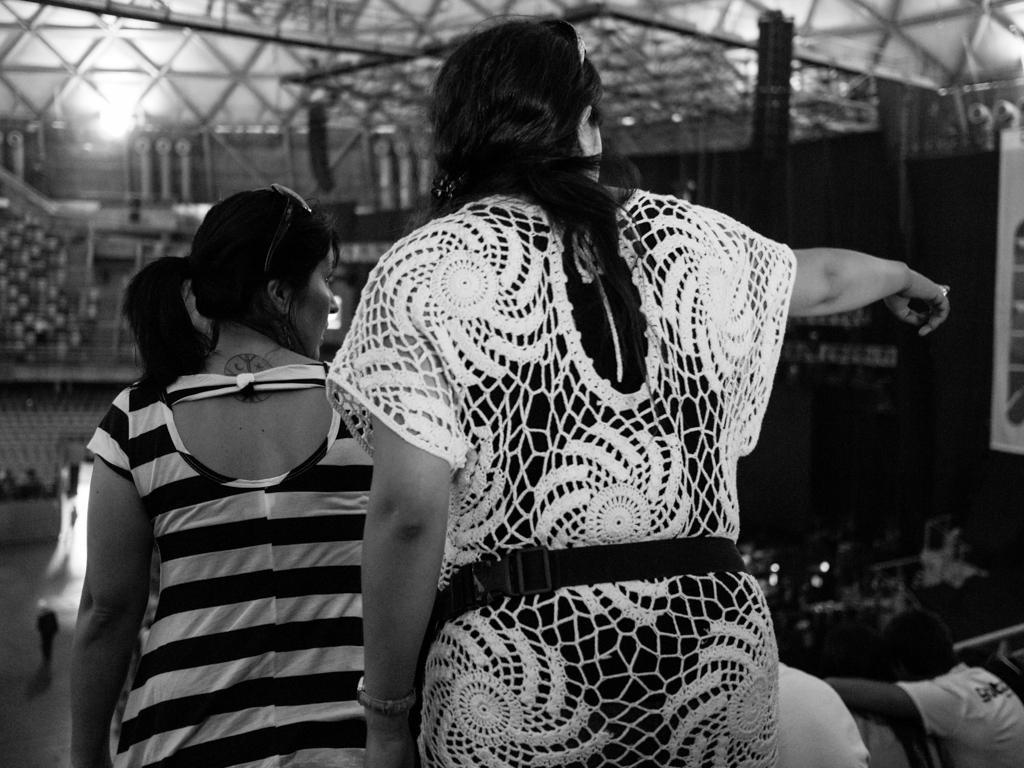Can you describe this image briefly? This is a black and white image. In this image we can see few people. In the background we can see light. Also there are some rods. 